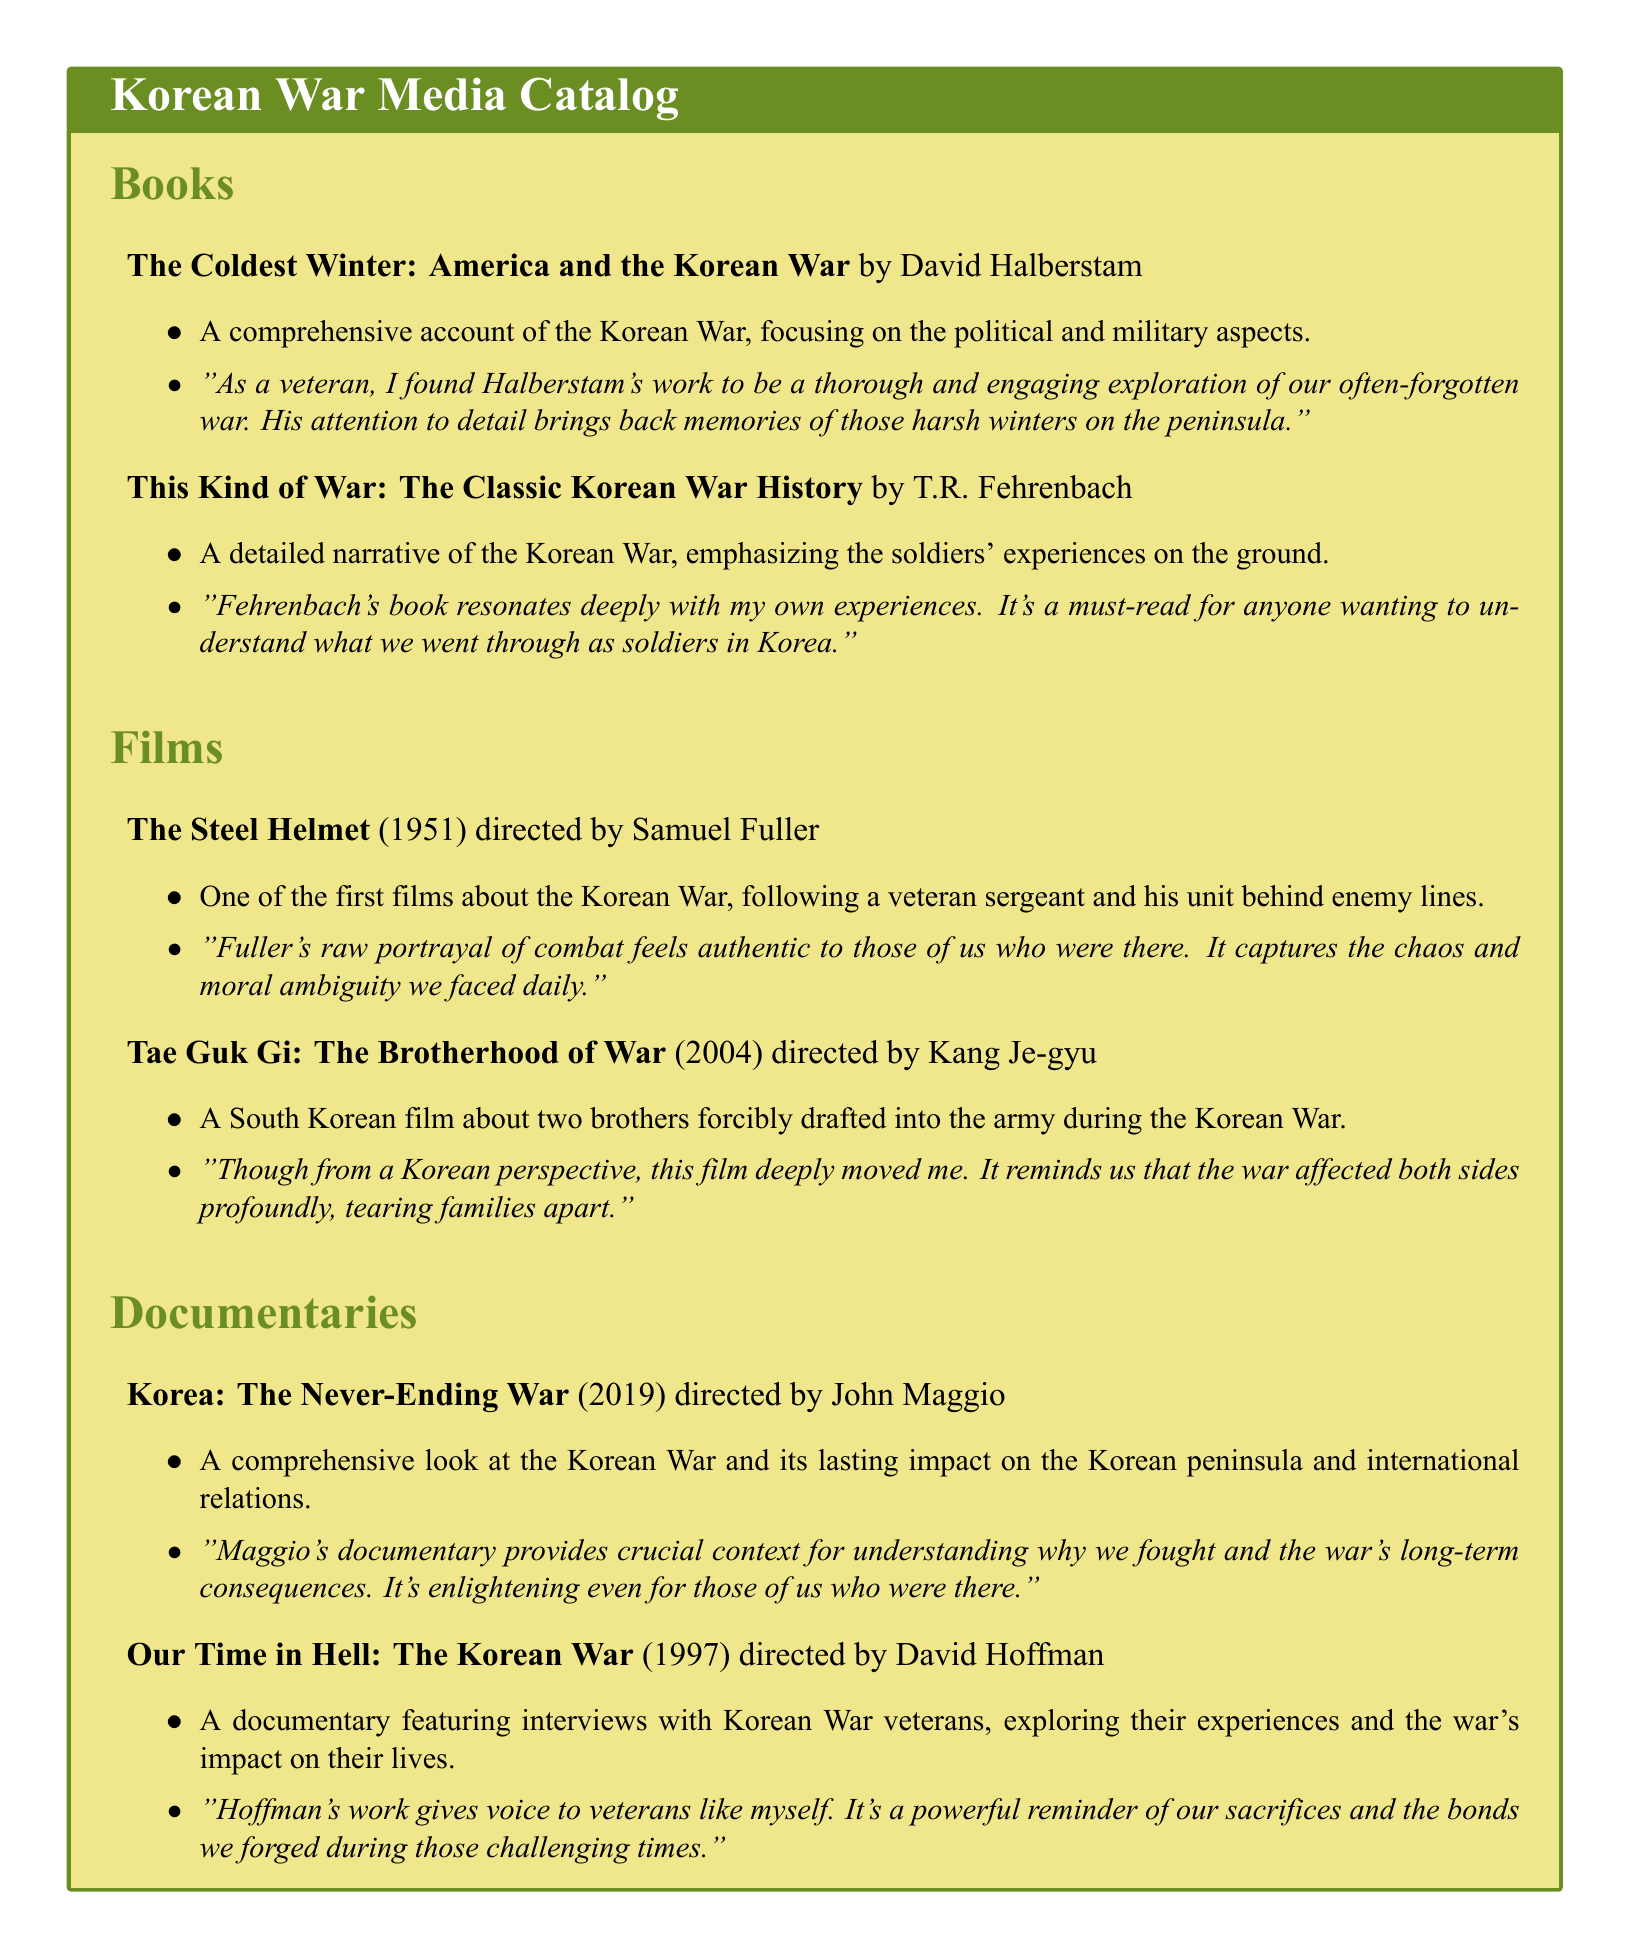What is the title of the book by David Halberstam? The title can be found in the 'Books' section, where it lists his work.
Answer: The Coldest Winter: America and the Korean War Who directed "The Steel Helmet"? The director's name is stated alongside the film in the 'Films' section of the document.
Answer: Samuel Fuller What year was "Our Time in Hell: The Korean War" released? The release year of the documentary is mentioned next to its title in the 'Documentaries' section.
Answer: 1997 How many veterans' experiences does "Our Time in Hell" explore? This information can be inferred from the description that mentions interviews with Korean War veterans.
Answer: Interviews with Korean War veterans What type of media is "Korea: The Never-Ending War"? This can be determined based on the classification of items in the document, which separates books, films, and documentaries.
Answer: Documentary 